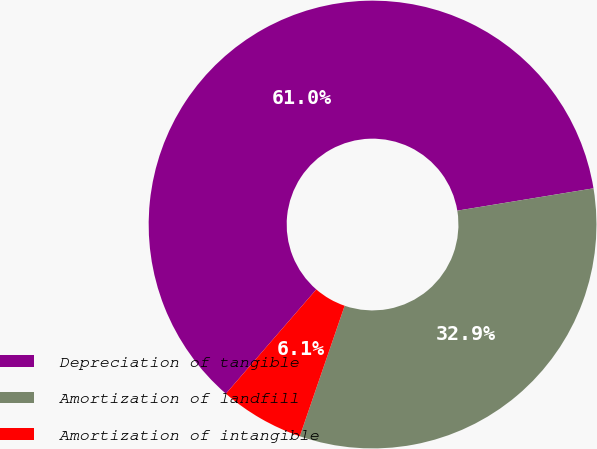Convert chart to OTSL. <chart><loc_0><loc_0><loc_500><loc_500><pie_chart><fcel>Depreciation of tangible<fcel>Amortization of landfill<fcel>Amortization of intangible<nl><fcel>61.04%<fcel>32.85%<fcel>6.1%<nl></chart> 